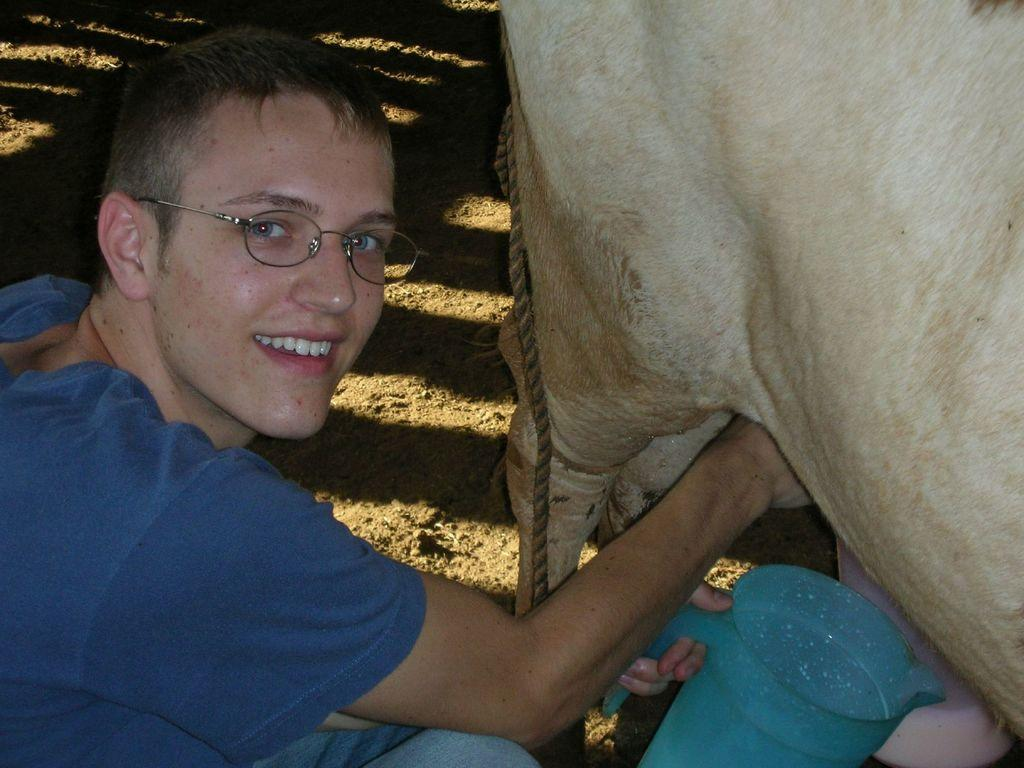What is the man in the image holding? The man is holding a jug in his hand. What can be seen on the right side of the image? There is an animal and a container placed on the ground on the right side of the image. Can you describe the rope visible in the image? Yes, there is a rope visible in the image. What type of bed can be seen in the image? There is no bed present in the image. How does the rope taste in the image? The rope is not meant to be tasted, and there is no indication of its taste in the image. 